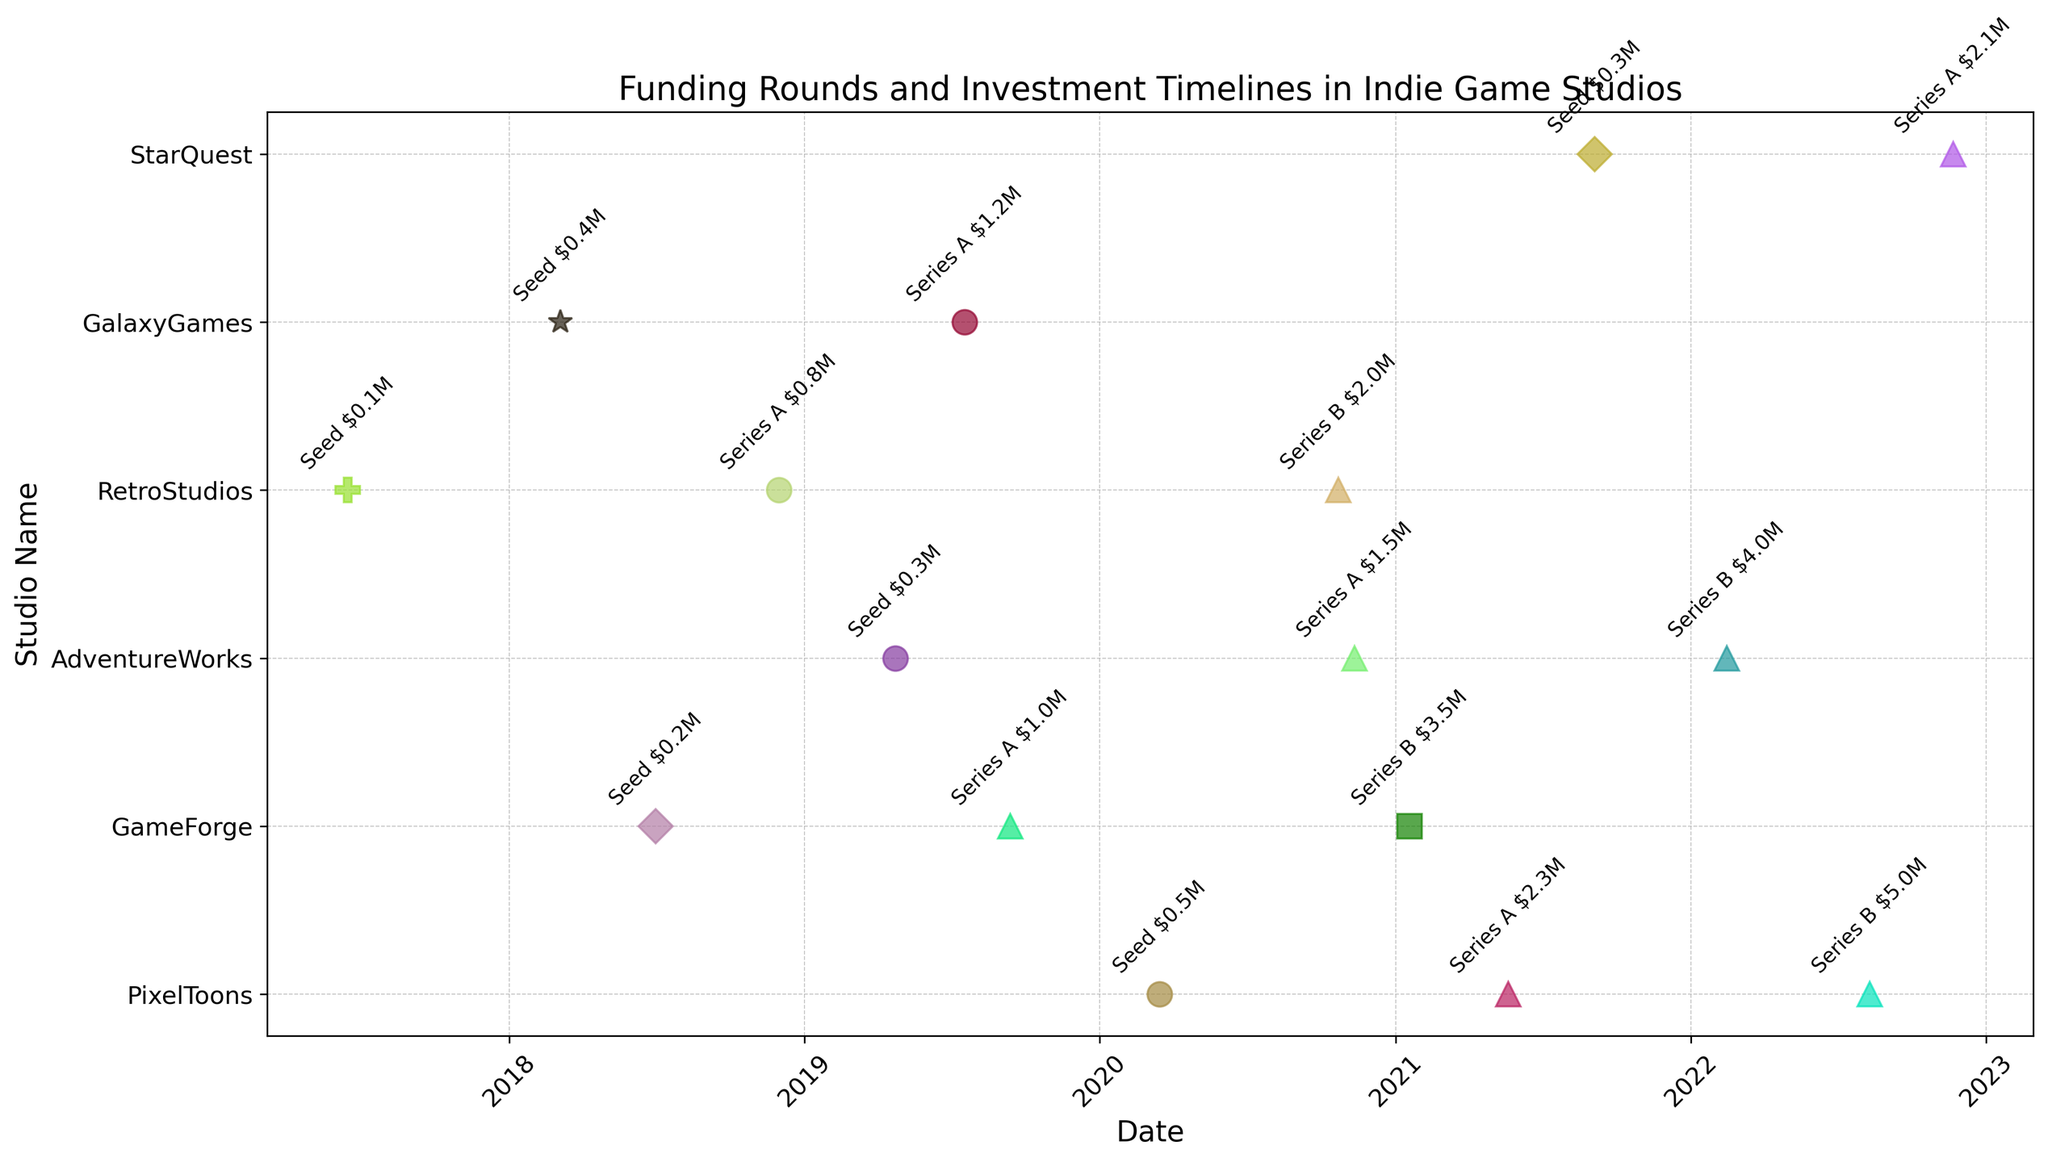What is the total amount raised by PixelToons after all funding rounds? To find the total amount raised by PixelToons, sum up the amounts from all its funding rounds: $0.5M (Seed) + $2.3M (Series A) + $5.0M (Series B) = $7.8M.
Answer: $7.8M Which studio had the earliest funding round, and what type was it? By looking at the dates on the timeline, the earliest funding round is by RetroStudios on 2017-06-15, and the type is Accelerator.
Answer: RetroStudios, Accelerator Compare the Series A funding amounts of GameForge and AdventureWorks. Which studio raised more, and by how much? GameForge raised $1.0M in Series A, while AdventureWorks raised $1.5M in Series A. The difference is $1.5M - $1.0M = $0.5M, so AdventureWorks raised $0.5M more than GameForge.
Answer: AdventureWorks, $0.5M What is the average amount raised during the Seed rounds by all studios? Sum up the Seed round amounts: $0.5M (PixelToons) + $0.2M (GameForge) + $0.3M (AdventureWorks) + $0.1M (RetroStudios) + $0.4M (GalaxyGames) + $0.3M (StarQuest) = $1.8M. There are 6 Seed rounds, so the average is $1.8M / 6 = $0.3M.
Answer: $0.3M Which studio had the highest amount raised in a single funding round, and what was the amount? By reviewing the amounts on the timeline, PixelToons raised the highest amount in a single round with $5.0M during Series B.
Answer: PixelToons, $5.0M Order the studios from first to last Seed round date. According to the timeline, the order of studios from the earliest to the latest Seed round date is: RetroStudios (2017-06-15), GalaxyGames (2018-03-05), GameForge (2018-07-01), AdventureWorks (2019-04-23), PixelToons (2020-03-15), StarQuest (2021-09-04).
Answer: RetroStudios, GalaxyGames, GameForge, AdventureWorks, PixelToons, StarQuest Which type of funding round has the most instances across all studios? Count the number of each type directly from the figure: Angel (3), Venture Capital (6), Private Equity (1), Friends and Family (2), Accelerator (1), Crowdfunding (1). Venture Capital has the most instances.
Answer: Venture Capital During which year did GameForge raise the most total funding? Sum GameForge's funding amounts per year. 2018: $0.2M (Seed), 2019: $1.0M (Series A), 2021: $3.5M (Series B). 2021 has the highest total: $3.5M.
Answer: 2021 What is the time gap between the Seed round and the Series B round for AdventureWorks? AdventureWorks' Seed round was on 2019-04-23 and Series B was on 2022-02-14. Calculate the time gap: ~2 years 9 months.
Answer: ~2 years 9 months Which studio needed the longest time between their Seed round and Series A round? Calculate the time gaps for each studio: PixelToons (1 year, 2 months), GameForge (1 year, 2 months), AdventureWorks (1 year, 7 months), RetroStudios (1 year, 5 months), GalaxyGames (1 year, 4 months), StarQuest (1 year, 2 months). AdventureWorks needed the longest time from Seed to Series A round: 1 year, 7 months.
Answer: AdventureWorks 